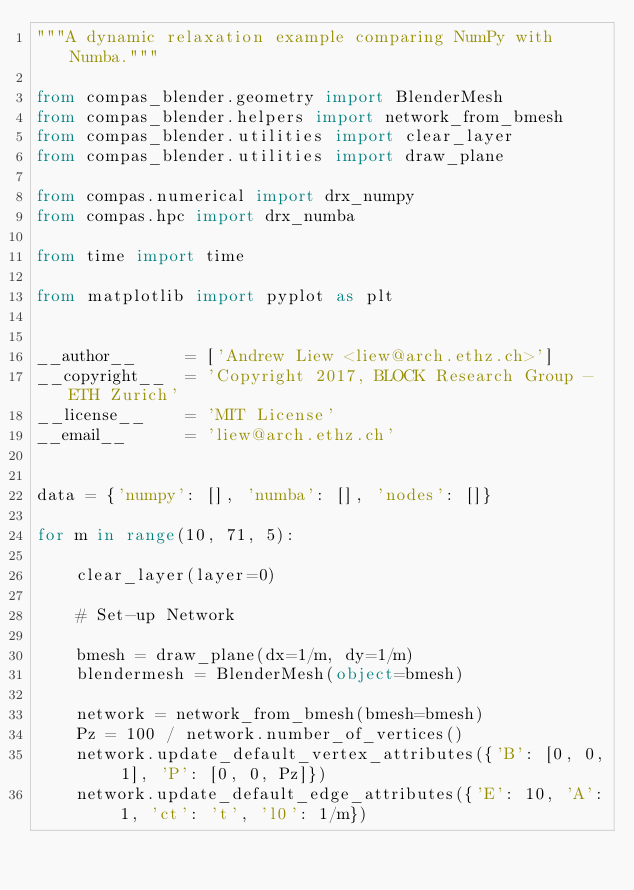Convert code to text. <code><loc_0><loc_0><loc_500><loc_500><_Python_>"""A dynamic relaxation example comparing NumPy with Numba."""

from compas_blender.geometry import BlenderMesh
from compas_blender.helpers import network_from_bmesh
from compas_blender.utilities import clear_layer
from compas_blender.utilities import draw_plane

from compas.numerical import drx_numpy
from compas.hpc import drx_numba

from time import time

from matplotlib import pyplot as plt


__author__     = ['Andrew Liew <liew@arch.ethz.ch>']
__copyright__  = 'Copyright 2017, BLOCK Research Group - ETH Zurich'
__license__    = 'MIT License'
__email__      = 'liew@arch.ethz.ch'


data = {'numpy': [], 'numba': [], 'nodes': []}

for m in range(10, 71, 5):

    clear_layer(layer=0)

    # Set-up Network

    bmesh = draw_plane(dx=1/m, dy=1/m)
    blendermesh = BlenderMesh(object=bmesh)

    network = network_from_bmesh(bmesh=bmesh)
    Pz = 100 / network.number_of_vertices()
    network.update_default_vertex_attributes({'B': [0, 0, 1], 'P': [0, 0, Pz]})
    network.update_default_edge_attributes({'E': 10, 'A': 1, 'ct': 't', 'l0': 1/m})</code> 